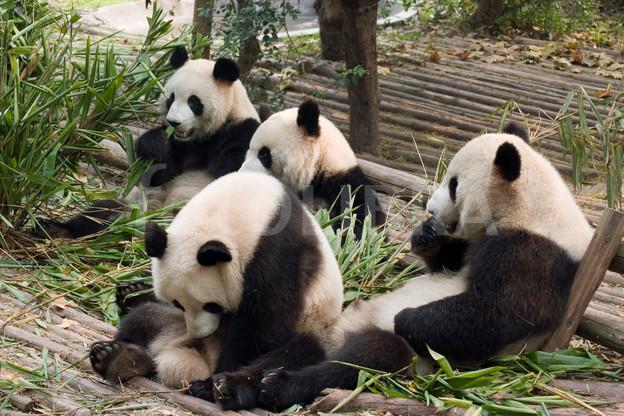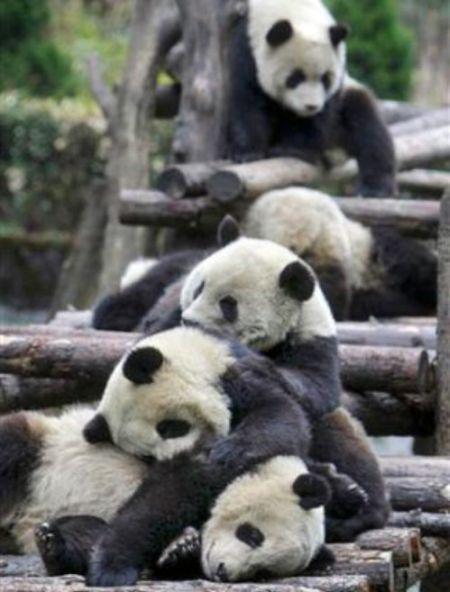The first image is the image on the left, the second image is the image on the right. Evaluate the accuracy of this statement regarding the images: "An image shows multiple pandas with green stalks for munching, on a structure of joined logs.". Is it true? Answer yes or no. Yes. The first image is the image on the left, the second image is the image on the right. For the images displayed, is the sentence "At least one panda is sitting in an open grassy area in one of the images." factually correct? Answer yes or no. No. 